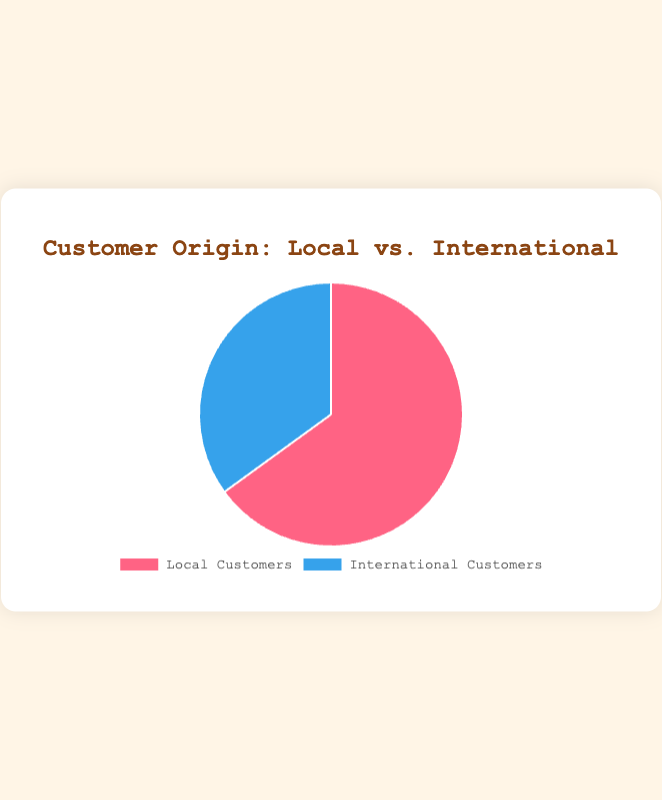What percentage of the restaurant's customers are local? Looking at the pie chart, "Local Customers" make up 65% of the total customer base.
Answer: 65% What percentage of the restaurant's customers are international? From the pie chart, it can be seen that "International Customers" account for 35% of the total customer base.
Answer: 35% Which group has more customers, local or international? The pie chart shows that "Local Customers" at 65% significantly outnumber "International Customers," who make up 35%.
Answer: Local Customers Is the number of local customers almost double that of international customers? To determine this, calculate 65% divided by 35%, which is approximately 1.86. This shows that the number of local customers is almost twice that of international customers.
Answer: Yes What is the difference in customer percentage between local and international customers? Subtract the percentage of "International Customers" from "Local Customers": 65% - 35% = 30%.
Answer: 30% How much more in terms of percentage is the local customer group compared to the international customer group? Calculate the difference: 65% - 35% = 30%. Therefore, local customers are 30% more than international customers.
Answer: 30% If the total number of customers is 200, how many of them are international? Calculate 35% of 200: 0.35 * 200 = 70. So, 70 customers are international.
Answer: 70 What fraction of the customers are local? The pie chart shows that "Local Customers" make up 65% of the total. As a fraction, 65% is equivalent to 65/100, which simplifies to 13/20.
Answer: 13/20 If the restaurant wants to increase its international customer base to match the local customer base, by what percentage should the international customer base increase? Currently, international customers are at 35%. To match local customers at 65%, calculate the required increase: (65% - 35%) / 35% * 100% = 85.7%. Therefore, the international customer base needs to increase by 85.7%.
Answer: 85.7% What color represents the local customers in the pie chart? The pie chart uses a red color to represent "Local Customers."
Answer: Red 